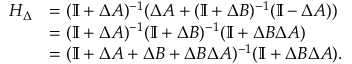Convert formula to latex. <formula><loc_0><loc_0><loc_500><loc_500>\begin{array} { r l } { H _ { \Delta } } & { = ( \mathbb { I } + \Delta A ) ^ { - 1 } ( \Delta A + ( \mathbb { I } + \Delta B ) ^ { - 1 } ( \mathbb { I } - \Delta A ) ) } \\ & { = ( \mathbb { I } + \Delta A ) ^ { - 1 } ( \mathbb { I } + \Delta B ) ^ { - 1 } ( \mathbb { I } + \Delta B \Delta A ) } \\ & { = ( \mathbb { I } + \Delta A + \Delta B + \Delta B \Delta A ) ^ { - 1 } ( \mathbb { I } + \Delta B \Delta A ) . } \end{array}</formula> 